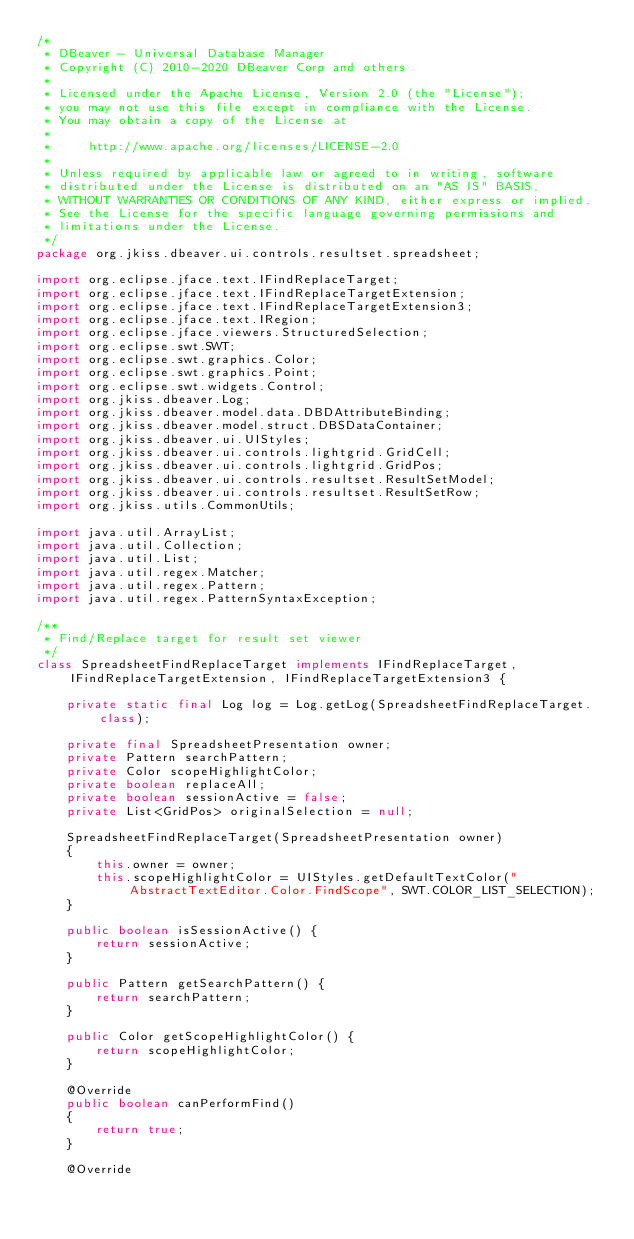<code> <loc_0><loc_0><loc_500><loc_500><_Java_>/*
 * DBeaver - Universal Database Manager
 * Copyright (C) 2010-2020 DBeaver Corp and others
 *
 * Licensed under the Apache License, Version 2.0 (the "License");
 * you may not use this file except in compliance with the License.
 * You may obtain a copy of the License at
 *
 *     http://www.apache.org/licenses/LICENSE-2.0
 *
 * Unless required by applicable law or agreed to in writing, software
 * distributed under the License is distributed on an "AS IS" BASIS,
 * WITHOUT WARRANTIES OR CONDITIONS OF ANY KIND, either express or implied.
 * See the License for the specific language governing permissions and
 * limitations under the License.
 */
package org.jkiss.dbeaver.ui.controls.resultset.spreadsheet;

import org.eclipse.jface.text.IFindReplaceTarget;
import org.eclipse.jface.text.IFindReplaceTargetExtension;
import org.eclipse.jface.text.IFindReplaceTargetExtension3;
import org.eclipse.jface.text.IRegion;
import org.eclipse.jface.viewers.StructuredSelection;
import org.eclipse.swt.SWT;
import org.eclipse.swt.graphics.Color;
import org.eclipse.swt.graphics.Point;
import org.eclipse.swt.widgets.Control;
import org.jkiss.dbeaver.Log;
import org.jkiss.dbeaver.model.data.DBDAttributeBinding;
import org.jkiss.dbeaver.model.struct.DBSDataContainer;
import org.jkiss.dbeaver.ui.UIStyles;
import org.jkiss.dbeaver.ui.controls.lightgrid.GridCell;
import org.jkiss.dbeaver.ui.controls.lightgrid.GridPos;
import org.jkiss.dbeaver.ui.controls.resultset.ResultSetModel;
import org.jkiss.dbeaver.ui.controls.resultset.ResultSetRow;
import org.jkiss.utils.CommonUtils;

import java.util.ArrayList;
import java.util.Collection;
import java.util.List;
import java.util.regex.Matcher;
import java.util.regex.Pattern;
import java.util.regex.PatternSyntaxException;

/**
 * Find/Replace target for result set viewer
 */
class SpreadsheetFindReplaceTarget implements IFindReplaceTarget, IFindReplaceTargetExtension, IFindReplaceTargetExtension3 {

    private static final Log log = Log.getLog(SpreadsheetFindReplaceTarget.class);

    private final SpreadsheetPresentation owner;
    private Pattern searchPattern;
    private Color scopeHighlightColor;
    private boolean replaceAll;
    private boolean sessionActive = false;
    private List<GridPos> originalSelection = null;

    SpreadsheetFindReplaceTarget(SpreadsheetPresentation owner)
    {
        this.owner = owner;
        this.scopeHighlightColor = UIStyles.getDefaultTextColor("AbstractTextEditor.Color.FindScope", SWT.COLOR_LIST_SELECTION);
    }

    public boolean isSessionActive() {
        return sessionActive;
    }

    public Pattern getSearchPattern() {
        return searchPattern;
    }

    public Color getScopeHighlightColor() {
        return scopeHighlightColor;
    }

    @Override
    public boolean canPerformFind()
    {
        return true;
    }

    @Override</code> 